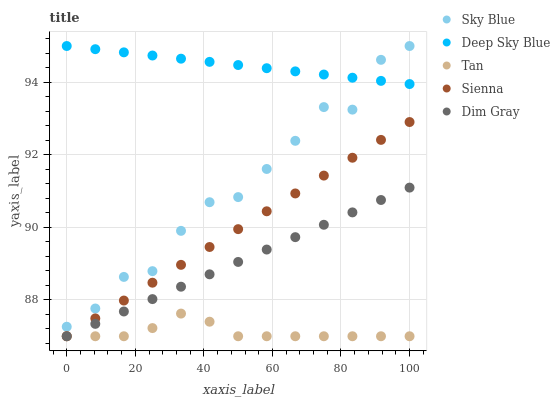Does Tan have the minimum area under the curve?
Answer yes or no. Yes. Does Deep Sky Blue have the maximum area under the curve?
Answer yes or no. Yes. Does Sky Blue have the minimum area under the curve?
Answer yes or no. No. Does Sky Blue have the maximum area under the curve?
Answer yes or no. No. Is Dim Gray the smoothest?
Answer yes or no. Yes. Is Sky Blue the roughest?
Answer yes or no. Yes. Is Tan the smoothest?
Answer yes or no. No. Is Tan the roughest?
Answer yes or no. No. Does Sienna have the lowest value?
Answer yes or no. Yes. Does Sky Blue have the lowest value?
Answer yes or no. No. Does Deep Sky Blue have the highest value?
Answer yes or no. Yes. Does Tan have the highest value?
Answer yes or no. No. Is Sienna less than Sky Blue?
Answer yes or no. Yes. Is Deep Sky Blue greater than Sienna?
Answer yes or no. Yes. Does Dim Gray intersect Tan?
Answer yes or no. Yes. Is Dim Gray less than Tan?
Answer yes or no. No. Is Dim Gray greater than Tan?
Answer yes or no. No. Does Sienna intersect Sky Blue?
Answer yes or no. No. 